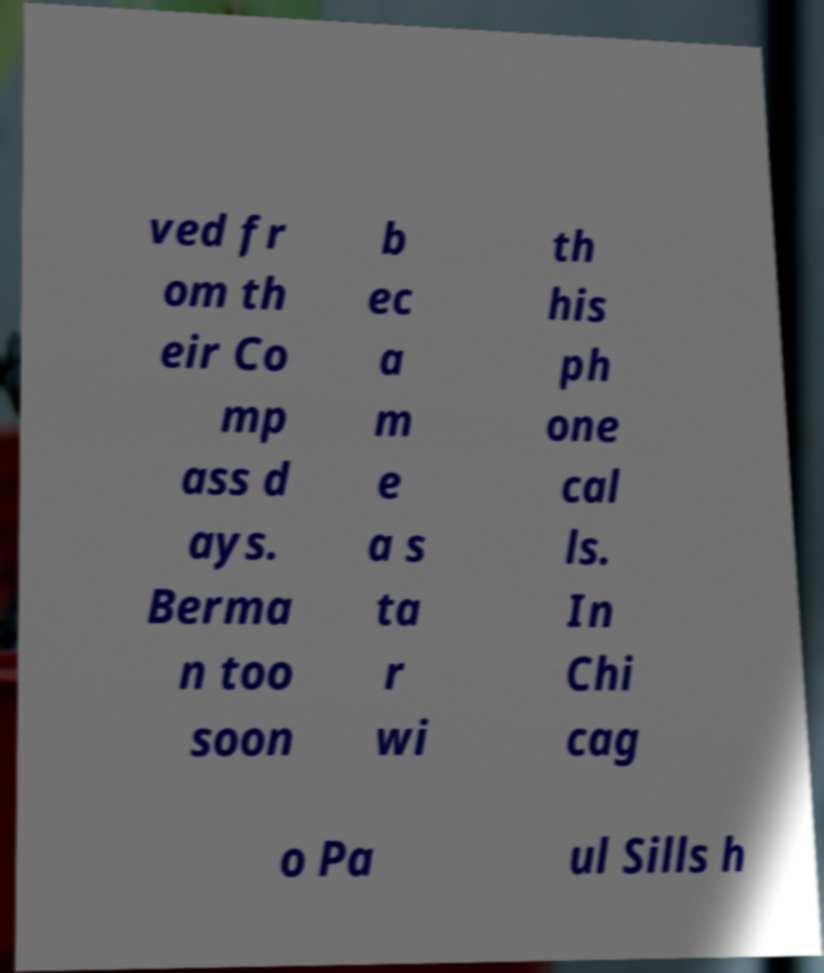For documentation purposes, I need the text within this image transcribed. Could you provide that? ved fr om th eir Co mp ass d ays. Berma n too soon b ec a m e a s ta r wi th his ph one cal ls. In Chi cag o Pa ul Sills h 